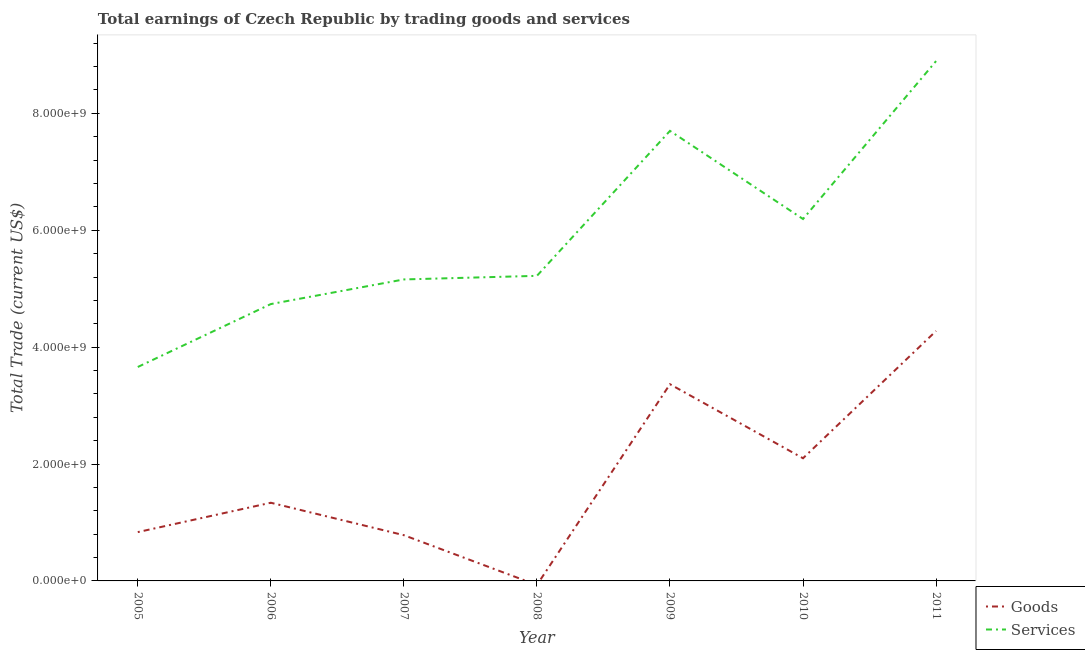How many different coloured lines are there?
Your response must be concise. 2. Is the number of lines equal to the number of legend labels?
Offer a very short reply. No. What is the amount earned by trading goods in 2006?
Your answer should be compact. 1.34e+09. Across all years, what is the maximum amount earned by trading goods?
Make the answer very short. 4.28e+09. Across all years, what is the minimum amount earned by trading services?
Provide a succinct answer. 3.66e+09. In which year was the amount earned by trading services maximum?
Offer a terse response. 2011. What is the total amount earned by trading goods in the graph?
Your response must be concise. 1.27e+1. What is the difference between the amount earned by trading goods in 2005 and that in 2011?
Offer a very short reply. -3.44e+09. What is the difference between the amount earned by trading services in 2009 and the amount earned by trading goods in 2006?
Offer a terse response. 6.36e+09. What is the average amount earned by trading goods per year?
Provide a short and direct response. 1.81e+09. In the year 2011, what is the difference between the amount earned by trading goods and amount earned by trading services?
Offer a very short reply. -4.62e+09. What is the ratio of the amount earned by trading goods in 2006 to that in 2010?
Ensure brevity in your answer.  0.64. Is the difference between the amount earned by trading services in 2007 and 2009 greater than the difference between the amount earned by trading goods in 2007 and 2009?
Give a very brief answer. Yes. What is the difference between the highest and the second highest amount earned by trading services?
Provide a succinct answer. 1.19e+09. What is the difference between the highest and the lowest amount earned by trading services?
Provide a succinct answer. 5.23e+09. Does the amount earned by trading goods monotonically increase over the years?
Ensure brevity in your answer.  No. Is the amount earned by trading goods strictly greater than the amount earned by trading services over the years?
Offer a terse response. No. Is the amount earned by trading goods strictly less than the amount earned by trading services over the years?
Give a very brief answer. Yes. What is the difference between two consecutive major ticks on the Y-axis?
Ensure brevity in your answer.  2.00e+09. Does the graph contain any zero values?
Offer a very short reply. Yes. Where does the legend appear in the graph?
Keep it short and to the point. Bottom right. What is the title of the graph?
Make the answer very short. Total earnings of Czech Republic by trading goods and services. What is the label or title of the X-axis?
Keep it short and to the point. Year. What is the label or title of the Y-axis?
Your answer should be very brief. Total Trade (current US$). What is the Total Trade (current US$) of Goods in 2005?
Your answer should be very brief. 8.35e+08. What is the Total Trade (current US$) in Services in 2005?
Keep it short and to the point. 3.66e+09. What is the Total Trade (current US$) of Goods in 2006?
Your response must be concise. 1.34e+09. What is the Total Trade (current US$) in Services in 2006?
Make the answer very short. 4.74e+09. What is the Total Trade (current US$) in Goods in 2007?
Your answer should be compact. 7.83e+08. What is the Total Trade (current US$) of Services in 2007?
Make the answer very short. 5.16e+09. What is the Total Trade (current US$) in Goods in 2008?
Your response must be concise. 0. What is the Total Trade (current US$) in Services in 2008?
Provide a succinct answer. 5.22e+09. What is the Total Trade (current US$) in Goods in 2009?
Provide a succinct answer. 3.37e+09. What is the Total Trade (current US$) in Services in 2009?
Make the answer very short. 7.70e+09. What is the Total Trade (current US$) in Goods in 2010?
Offer a terse response. 2.10e+09. What is the Total Trade (current US$) in Services in 2010?
Your response must be concise. 6.19e+09. What is the Total Trade (current US$) of Goods in 2011?
Ensure brevity in your answer.  4.28e+09. What is the Total Trade (current US$) of Services in 2011?
Your answer should be very brief. 8.89e+09. Across all years, what is the maximum Total Trade (current US$) of Goods?
Provide a succinct answer. 4.28e+09. Across all years, what is the maximum Total Trade (current US$) in Services?
Keep it short and to the point. 8.89e+09. Across all years, what is the minimum Total Trade (current US$) in Goods?
Make the answer very short. 0. Across all years, what is the minimum Total Trade (current US$) of Services?
Your answer should be very brief. 3.66e+09. What is the total Total Trade (current US$) in Goods in the graph?
Offer a terse response. 1.27e+1. What is the total Total Trade (current US$) in Services in the graph?
Offer a terse response. 4.16e+1. What is the difference between the Total Trade (current US$) in Goods in 2005 and that in 2006?
Ensure brevity in your answer.  -5.02e+08. What is the difference between the Total Trade (current US$) of Services in 2005 and that in 2006?
Give a very brief answer. -1.08e+09. What is the difference between the Total Trade (current US$) in Goods in 2005 and that in 2007?
Your answer should be compact. 5.27e+07. What is the difference between the Total Trade (current US$) in Services in 2005 and that in 2007?
Ensure brevity in your answer.  -1.50e+09. What is the difference between the Total Trade (current US$) of Services in 2005 and that in 2008?
Your answer should be compact. -1.56e+09. What is the difference between the Total Trade (current US$) of Goods in 2005 and that in 2009?
Your answer should be compact. -2.53e+09. What is the difference between the Total Trade (current US$) of Services in 2005 and that in 2009?
Provide a succinct answer. -4.04e+09. What is the difference between the Total Trade (current US$) of Goods in 2005 and that in 2010?
Keep it short and to the point. -1.26e+09. What is the difference between the Total Trade (current US$) of Services in 2005 and that in 2010?
Your answer should be compact. -2.53e+09. What is the difference between the Total Trade (current US$) in Goods in 2005 and that in 2011?
Provide a short and direct response. -3.44e+09. What is the difference between the Total Trade (current US$) of Services in 2005 and that in 2011?
Give a very brief answer. -5.23e+09. What is the difference between the Total Trade (current US$) in Goods in 2006 and that in 2007?
Offer a terse response. 5.55e+08. What is the difference between the Total Trade (current US$) of Services in 2006 and that in 2007?
Provide a short and direct response. -4.21e+08. What is the difference between the Total Trade (current US$) in Services in 2006 and that in 2008?
Your answer should be compact. -4.83e+08. What is the difference between the Total Trade (current US$) in Goods in 2006 and that in 2009?
Give a very brief answer. -2.03e+09. What is the difference between the Total Trade (current US$) in Services in 2006 and that in 2009?
Your answer should be very brief. -2.96e+09. What is the difference between the Total Trade (current US$) in Goods in 2006 and that in 2010?
Keep it short and to the point. -7.61e+08. What is the difference between the Total Trade (current US$) in Services in 2006 and that in 2010?
Make the answer very short. -1.46e+09. What is the difference between the Total Trade (current US$) in Goods in 2006 and that in 2011?
Give a very brief answer. -2.94e+09. What is the difference between the Total Trade (current US$) of Services in 2006 and that in 2011?
Give a very brief answer. -4.16e+09. What is the difference between the Total Trade (current US$) of Services in 2007 and that in 2008?
Ensure brevity in your answer.  -6.16e+07. What is the difference between the Total Trade (current US$) in Goods in 2007 and that in 2009?
Keep it short and to the point. -2.58e+09. What is the difference between the Total Trade (current US$) in Services in 2007 and that in 2009?
Ensure brevity in your answer.  -2.54e+09. What is the difference between the Total Trade (current US$) of Goods in 2007 and that in 2010?
Your answer should be very brief. -1.32e+09. What is the difference between the Total Trade (current US$) of Services in 2007 and that in 2010?
Your answer should be very brief. -1.03e+09. What is the difference between the Total Trade (current US$) in Goods in 2007 and that in 2011?
Offer a terse response. -3.49e+09. What is the difference between the Total Trade (current US$) of Services in 2007 and that in 2011?
Give a very brief answer. -3.74e+09. What is the difference between the Total Trade (current US$) of Services in 2008 and that in 2009?
Make the answer very short. -2.48e+09. What is the difference between the Total Trade (current US$) in Services in 2008 and that in 2010?
Keep it short and to the point. -9.72e+08. What is the difference between the Total Trade (current US$) in Services in 2008 and that in 2011?
Make the answer very short. -3.67e+09. What is the difference between the Total Trade (current US$) in Goods in 2009 and that in 2010?
Offer a very short reply. 1.27e+09. What is the difference between the Total Trade (current US$) in Services in 2009 and that in 2010?
Offer a terse response. 1.51e+09. What is the difference between the Total Trade (current US$) in Goods in 2009 and that in 2011?
Ensure brevity in your answer.  -9.11e+08. What is the difference between the Total Trade (current US$) in Services in 2009 and that in 2011?
Offer a terse response. -1.19e+09. What is the difference between the Total Trade (current US$) of Goods in 2010 and that in 2011?
Give a very brief answer. -2.18e+09. What is the difference between the Total Trade (current US$) in Services in 2010 and that in 2011?
Keep it short and to the point. -2.70e+09. What is the difference between the Total Trade (current US$) of Goods in 2005 and the Total Trade (current US$) of Services in 2006?
Ensure brevity in your answer.  -3.90e+09. What is the difference between the Total Trade (current US$) in Goods in 2005 and the Total Trade (current US$) in Services in 2007?
Your answer should be compact. -4.32e+09. What is the difference between the Total Trade (current US$) of Goods in 2005 and the Total Trade (current US$) of Services in 2008?
Provide a succinct answer. -4.38e+09. What is the difference between the Total Trade (current US$) of Goods in 2005 and the Total Trade (current US$) of Services in 2009?
Keep it short and to the point. -6.86e+09. What is the difference between the Total Trade (current US$) in Goods in 2005 and the Total Trade (current US$) in Services in 2010?
Your response must be concise. -5.36e+09. What is the difference between the Total Trade (current US$) of Goods in 2005 and the Total Trade (current US$) of Services in 2011?
Keep it short and to the point. -8.06e+09. What is the difference between the Total Trade (current US$) of Goods in 2006 and the Total Trade (current US$) of Services in 2007?
Provide a short and direct response. -3.82e+09. What is the difference between the Total Trade (current US$) in Goods in 2006 and the Total Trade (current US$) in Services in 2008?
Give a very brief answer. -3.88e+09. What is the difference between the Total Trade (current US$) of Goods in 2006 and the Total Trade (current US$) of Services in 2009?
Make the answer very short. -6.36e+09. What is the difference between the Total Trade (current US$) in Goods in 2006 and the Total Trade (current US$) in Services in 2010?
Make the answer very short. -4.85e+09. What is the difference between the Total Trade (current US$) in Goods in 2006 and the Total Trade (current US$) in Services in 2011?
Provide a succinct answer. -7.56e+09. What is the difference between the Total Trade (current US$) in Goods in 2007 and the Total Trade (current US$) in Services in 2008?
Keep it short and to the point. -4.44e+09. What is the difference between the Total Trade (current US$) of Goods in 2007 and the Total Trade (current US$) of Services in 2009?
Make the answer very short. -6.92e+09. What is the difference between the Total Trade (current US$) in Goods in 2007 and the Total Trade (current US$) in Services in 2010?
Keep it short and to the point. -5.41e+09. What is the difference between the Total Trade (current US$) in Goods in 2007 and the Total Trade (current US$) in Services in 2011?
Offer a terse response. -8.11e+09. What is the difference between the Total Trade (current US$) in Goods in 2009 and the Total Trade (current US$) in Services in 2010?
Offer a terse response. -2.83e+09. What is the difference between the Total Trade (current US$) of Goods in 2009 and the Total Trade (current US$) of Services in 2011?
Make the answer very short. -5.53e+09. What is the difference between the Total Trade (current US$) in Goods in 2010 and the Total Trade (current US$) in Services in 2011?
Give a very brief answer. -6.80e+09. What is the average Total Trade (current US$) in Goods per year?
Your answer should be compact. 1.81e+09. What is the average Total Trade (current US$) in Services per year?
Give a very brief answer. 5.94e+09. In the year 2005, what is the difference between the Total Trade (current US$) of Goods and Total Trade (current US$) of Services?
Provide a succinct answer. -2.83e+09. In the year 2006, what is the difference between the Total Trade (current US$) of Goods and Total Trade (current US$) of Services?
Give a very brief answer. -3.40e+09. In the year 2007, what is the difference between the Total Trade (current US$) of Goods and Total Trade (current US$) of Services?
Offer a very short reply. -4.38e+09. In the year 2009, what is the difference between the Total Trade (current US$) of Goods and Total Trade (current US$) of Services?
Provide a short and direct response. -4.33e+09. In the year 2010, what is the difference between the Total Trade (current US$) of Goods and Total Trade (current US$) of Services?
Give a very brief answer. -4.09e+09. In the year 2011, what is the difference between the Total Trade (current US$) of Goods and Total Trade (current US$) of Services?
Your response must be concise. -4.62e+09. What is the ratio of the Total Trade (current US$) in Goods in 2005 to that in 2006?
Offer a terse response. 0.62. What is the ratio of the Total Trade (current US$) in Services in 2005 to that in 2006?
Give a very brief answer. 0.77. What is the ratio of the Total Trade (current US$) in Goods in 2005 to that in 2007?
Your response must be concise. 1.07. What is the ratio of the Total Trade (current US$) in Services in 2005 to that in 2007?
Give a very brief answer. 0.71. What is the ratio of the Total Trade (current US$) of Services in 2005 to that in 2008?
Your response must be concise. 0.7. What is the ratio of the Total Trade (current US$) in Goods in 2005 to that in 2009?
Your response must be concise. 0.25. What is the ratio of the Total Trade (current US$) in Services in 2005 to that in 2009?
Ensure brevity in your answer.  0.48. What is the ratio of the Total Trade (current US$) of Goods in 2005 to that in 2010?
Provide a succinct answer. 0.4. What is the ratio of the Total Trade (current US$) in Services in 2005 to that in 2010?
Offer a very short reply. 0.59. What is the ratio of the Total Trade (current US$) in Goods in 2005 to that in 2011?
Your answer should be compact. 0.2. What is the ratio of the Total Trade (current US$) in Services in 2005 to that in 2011?
Your answer should be compact. 0.41. What is the ratio of the Total Trade (current US$) in Goods in 2006 to that in 2007?
Provide a short and direct response. 1.71. What is the ratio of the Total Trade (current US$) in Services in 2006 to that in 2007?
Provide a short and direct response. 0.92. What is the ratio of the Total Trade (current US$) of Services in 2006 to that in 2008?
Provide a succinct answer. 0.91. What is the ratio of the Total Trade (current US$) of Goods in 2006 to that in 2009?
Your answer should be very brief. 0.4. What is the ratio of the Total Trade (current US$) in Services in 2006 to that in 2009?
Provide a short and direct response. 0.62. What is the ratio of the Total Trade (current US$) of Goods in 2006 to that in 2010?
Your answer should be compact. 0.64. What is the ratio of the Total Trade (current US$) of Services in 2006 to that in 2010?
Offer a very short reply. 0.77. What is the ratio of the Total Trade (current US$) in Goods in 2006 to that in 2011?
Offer a very short reply. 0.31. What is the ratio of the Total Trade (current US$) of Services in 2006 to that in 2011?
Offer a very short reply. 0.53. What is the ratio of the Total Trade (current US$) in Goods in 2007 to that in 2009?
Make the answer very short. 0.23. What is the ratio of the Total Trade (current US$) of Services in 2007 to that in 2009?
Your answer should be very brief. 0.67. What is the ratio of the Total Trade (current US$) in Goods in 2007 to that in 2010?
Make the answer very short. 0.37. What is the ratio of the Total Trade (current US$) of Services in 2007 to that in 2010?
Your answer should be compact. 0.83. What is the ratio of the Total Trade (current US$) in Goods in 2007 to that in 2011?
Provide a succinct answer. 0.18. What is the ratio of the Total Trade (current US$) in Services in 2007 to that in 2011?
Your answer should be very brief. 0.58. What is the ratio of the Total Trade (current US$) of Services in 2008 to that in 2009?
Keep it short and to the point. 0.68. What is the ratio of the Total Trade (current US$) in Services in 2008 to that in 2010?
Offer a very short reply. 0.84. What is the ratio of the Total Trade (current US$) in Services in 2008 to that in 2011?
Offer a very short reply. 0.59. What is the ratio of the Total Trade (current US$) of Goods in 2009 to that in 2010?
Your answer should be compact. 1.6. What is the ratio of the Total Trade (current US$) in Services in 2009 to that in 2010?
Provide a short and direct response. 1.24. What is the ratio of the Total Trade (current US$) of Goods in 2009 to that in 2011?
Offer a very short reply. 0.79. What is the ratio of the Total Trade (current US$) in Services in 2009 to that in 2011?
Your response must be concise. 0.87. What is the ratio of the Total Trade (current US$) of Goods in 2010 to that in 2011?
Keep it short and to the point. 0.49. What is the ratio of the Total Trade (current US$) in Services in 2010 to that in 2011?
Provide a succinct answer. 0.7. What is the difference between the highest and the second highest Total Trade (current US$) of Goods?
Provide a succinct answer. 9.11e+08. What is the difference between the highest and the second highest Total Trade (current US$) in Services?
Ensure brevity in your answer.  1.19e+09. What is the difference between the highest and the lowest Total Trade (current US$) of Goods?
Provide a succinct answer. 4.28e+09. What is the difference between the highest and the lowest Total Trade (current US$) in Services?
Provide a succinct answer. 5.23e+09. 